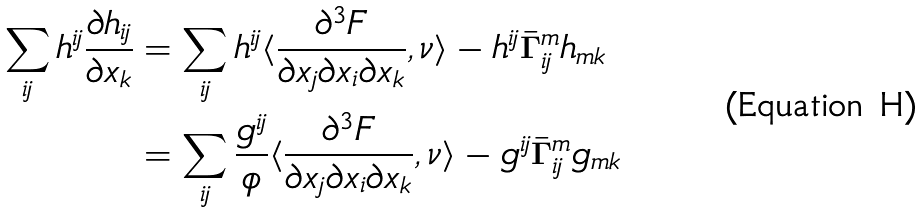<formula> <loc_0><loc_0><loc_500><loc_500>\sum _ { i j } h ^ { i j } \frac { \partial h _ { i j } } { \partial x _ { k } } & = \sum _ { i j } h ^ { i j } \langle \frac { \partial ^ { 3 } F } { \partial x _ { j } \partial x _ { i } \partial x _ { k } } , \nu \rangle - h ^ { i j } \bar { \Gamma } ^ { m } _ { i j } h _ { m k } \\ & = \sum _ { i j } \frac { g ^ { i j } } { \phi } \langle \frac { \partial ^ { 3 } F } { \partial x _ { j } \partial x _ { i } \partial x _ { k } } , \nu \rangle - g ^ { i j } \bar { \Gamma } ^ { m } _ { i j } g _ { m k }</formula> 